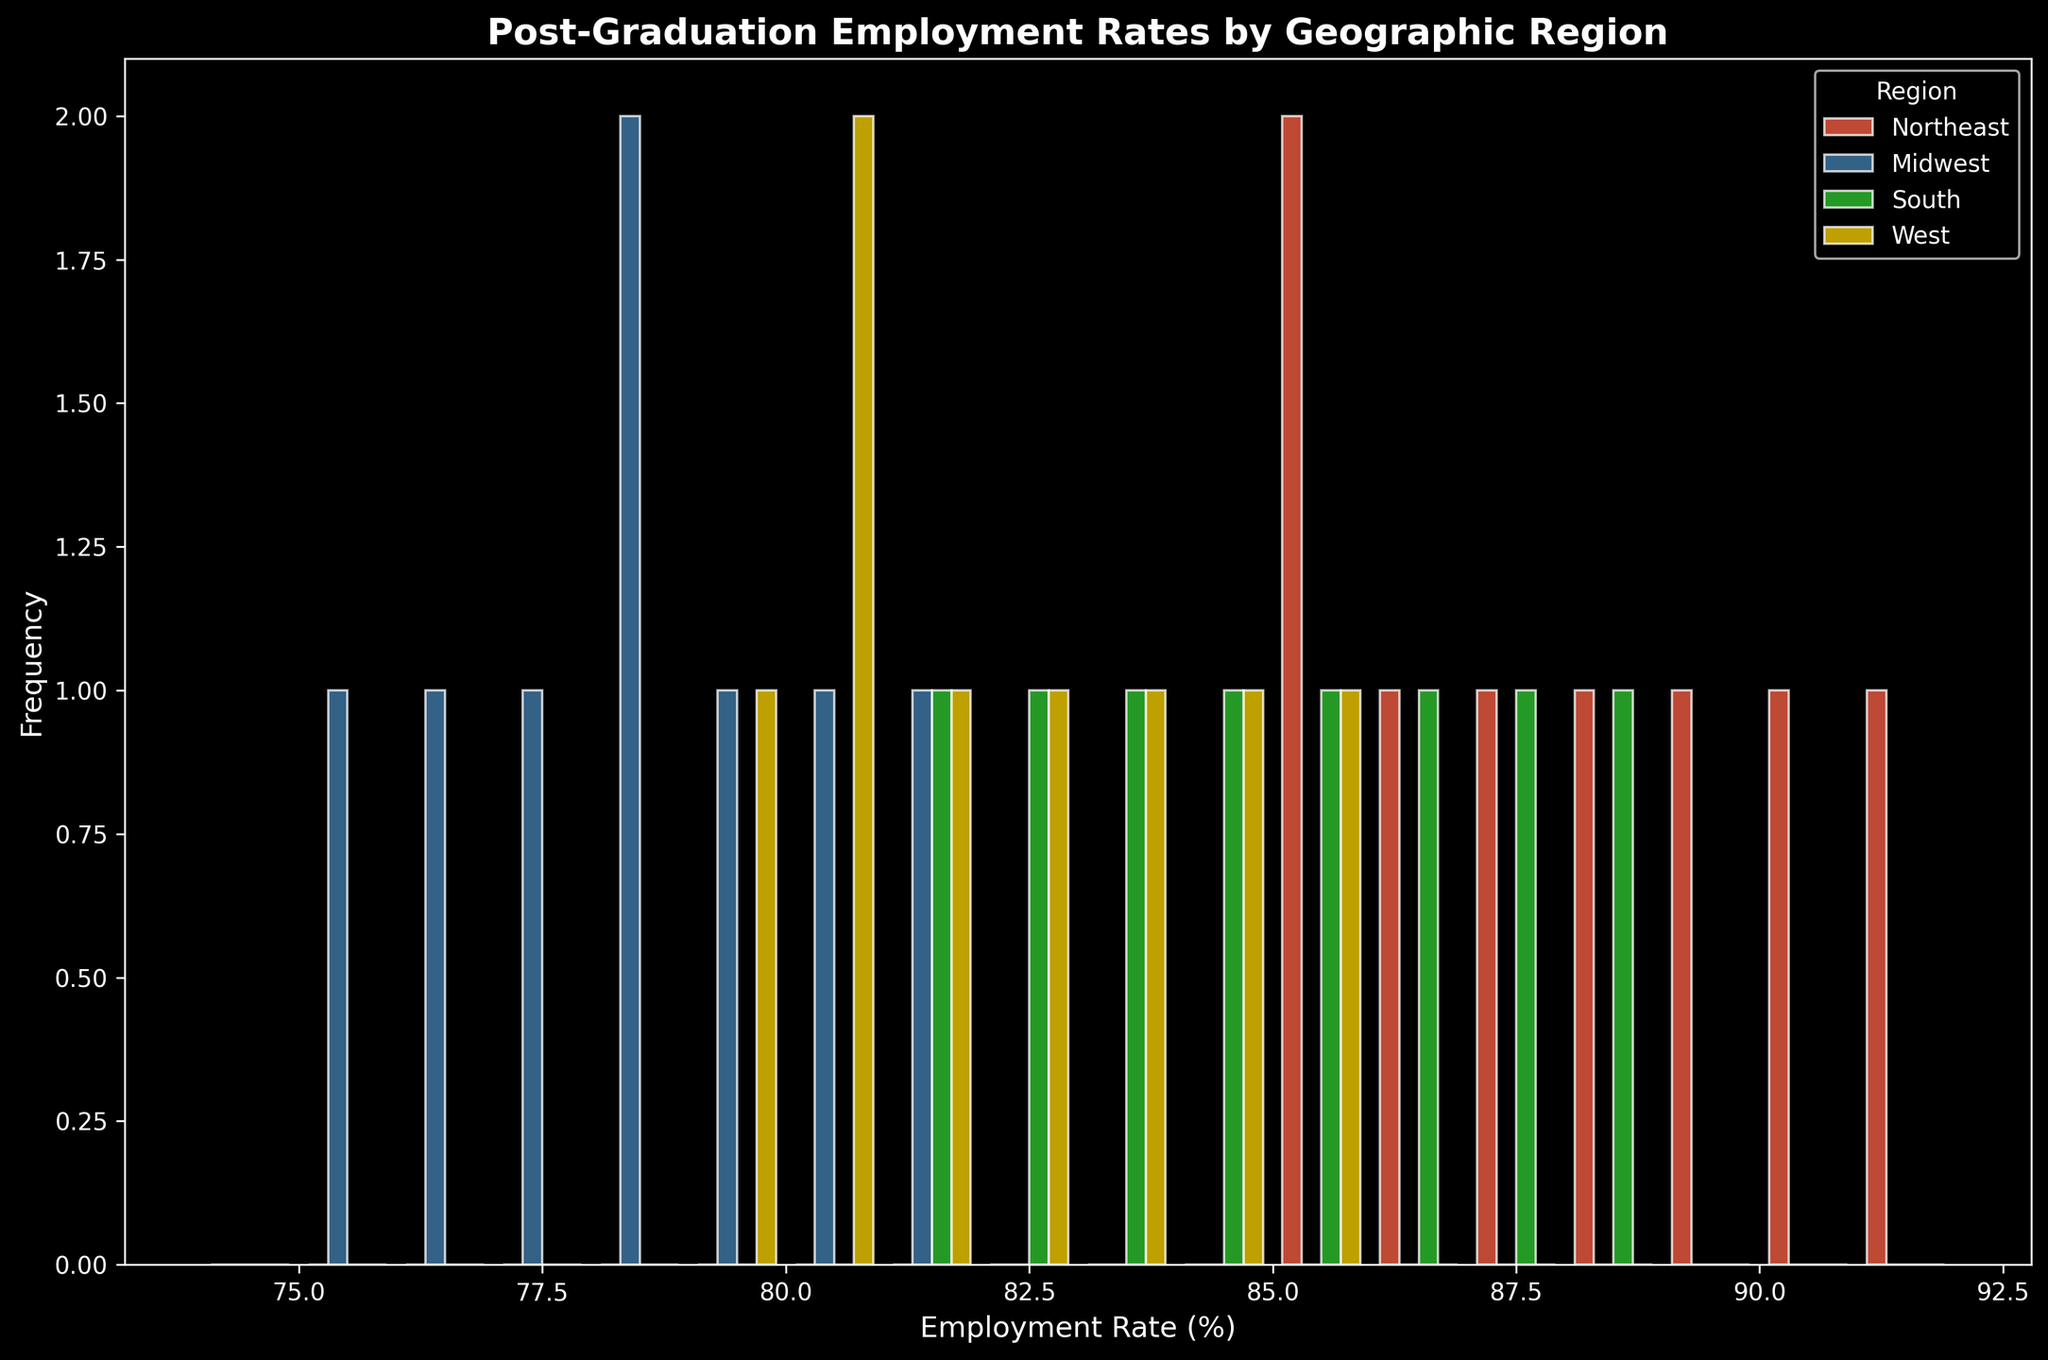What's the average employment rate for the Northeast region? To find the average employment rate of the Northeast region, sum all the employment rates for the Northeast and divide by the number of data points: (85 + 88 + 86 + 87 + 89 + 90 + 91 + 85) / 8 = 701 / 8 = 87.625
Answer: 87.625 Which region has the lowest maximum employment rate? Check the highest employment rate for each region and compare them. Northeast's maximum is 91%, Midwest's is 81%, South's is 88%, and West's is 85%. The Midwest has the lowest maximum employment rate.
Answer: Midwest What is the range of employment rates in the South region? Identify the highest and lowest employment rates for the South. The highest is 88% and the lowest is 81%. Subtract the lowest from the highest: 88 - 81 = 7.
Answer: 7 Which region appears the most frequently in the histogram? Examine the histogram and count the frequency of each region's bars. The Northeast appears most frequently with 8 data points compared to other regions.
Answer: Northeast How does the median employment rate compare between the Midwest and West regions? List the employment rates for Midwest (75, 76, 77, 78, 79, 80, 81) and West (79, 80, 81, 82, 83, 84, 85). Find the median values: Midwest's median is 78, West's median is 82.
Answer: West's median is higher Which visual color represents the South region? Look at the colors in the histogram's legend to find the one labeled "South". The yellow color represents the South region.
Answer: Yellow What is the most common employment rate range for the Northeast region? Analyze the frequency of the employment rate ranges in the histogram for the Northeast. The range 85-89% appears most frequently with 5 counts (85, 85, 86, 87, 88) within that range.
Answer: 85-89% Is there any overlapping in employment rates between the West and South regions? Identify ranges of employment rates for the West (79-85%) and South (81-88%). The overlapping range is from 81% to 85%.
Answer: Yes, from 81% to 85% By how much is the average employment rate in the South higher or lower than in the Midwest? First, calculate the average employment rates: South ((82 + 84 + 81 + 85 + 83 + 86 + 87 + 88) / 8 = 84.5), Midwest ((78 + 75 + 77 + 76 + 79 + 80 + 81) / 7 = 78). Subtract Midwest's average from South's average: 84.5 - 78 = 6.5.
Answer: 6.5 higher 